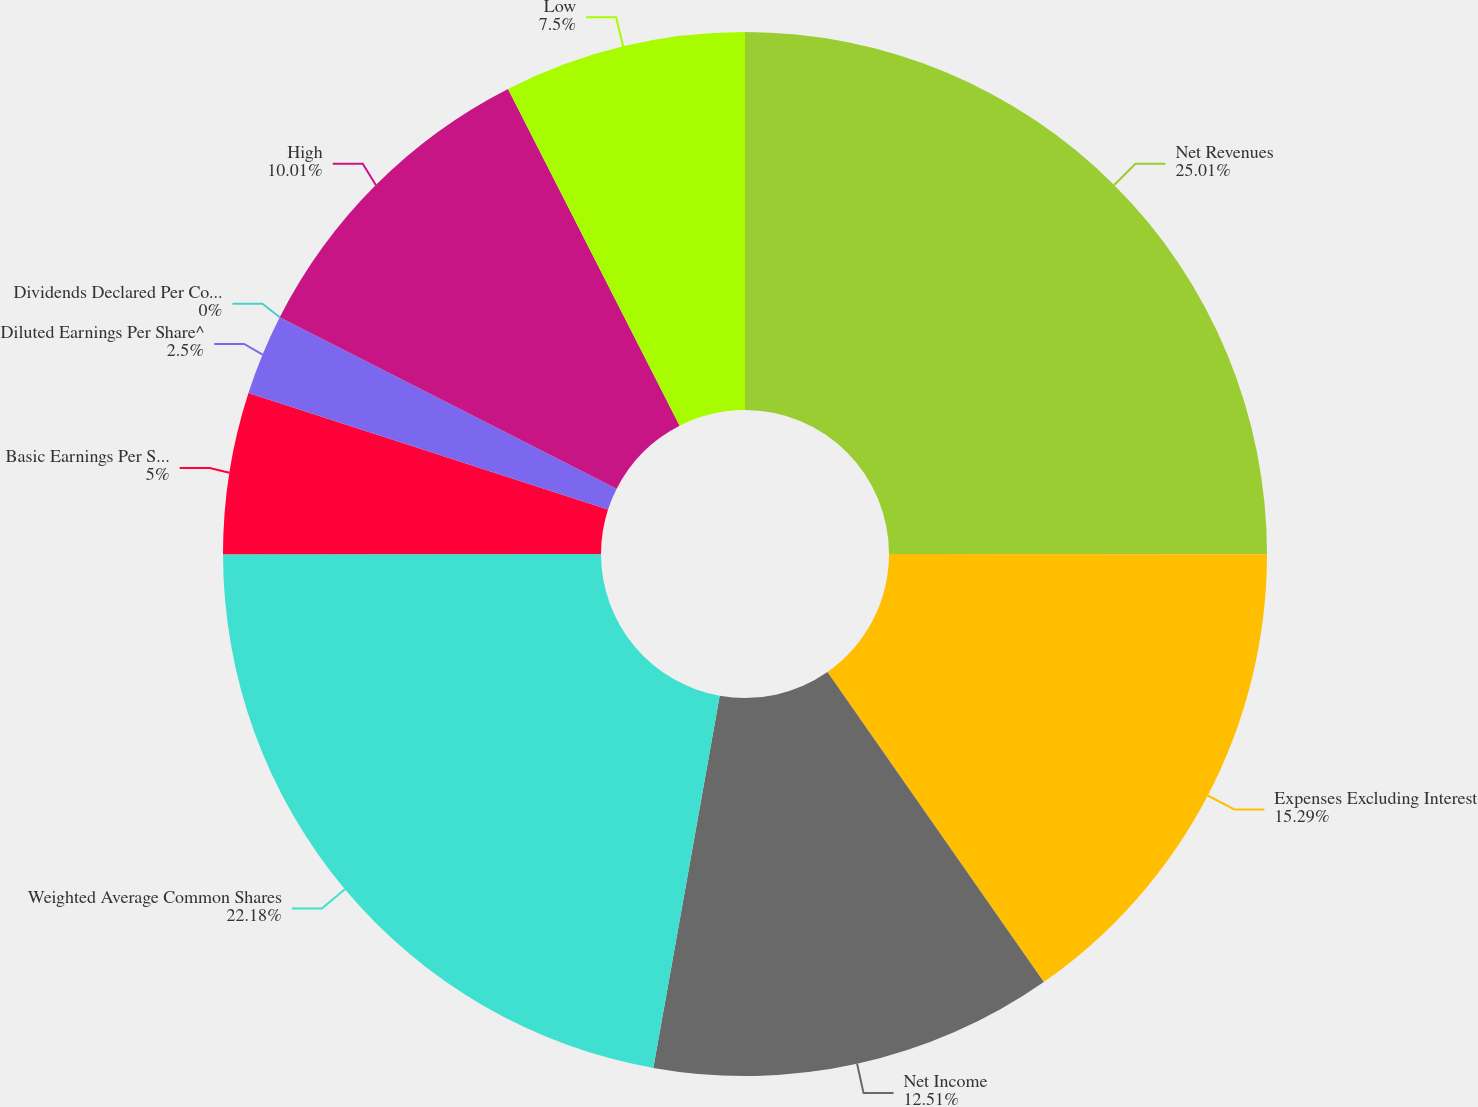Convert chart. <chart><loc_0><loc_0><loc_500><loc_500><pie_chart><fcel>Net Revenues<fcel>Expenses Excluding Interest<fcel>Net Income<fcel>Weighted Average Common Shares<fcel>Basic Earnings Per Share^ (1)<fcel>Diluted Earnings Per Share^<fcel>Dividends Declared Per Common<fcel>High<fcel>Low<nl><fcel>25.01%<fcel>15.29%<fcel>12.51%<fcel>22.18%<fcel>5.0%<fcel>2.5%<fcel>0.0%<fcel>10.01%<fcel>7.5%<nl></chart> 